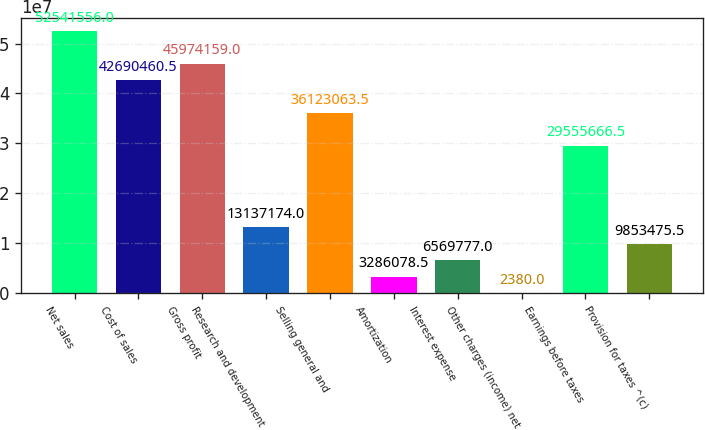<chart> <loc_0><loc_0><loc_500><loc_500><bar_chart><fcel>Net sales<fcel>Cost of sales<fcel>Gross profit<fcel>Research and development<fcel>Selling general and<fcel>Amortization<fcel>Interest expense<fcel>Other charges (income) net<fcel>Earnings before taxes<fcel>Provision for taxes ^(c)<nl><fcel>5.25416e+07<fcel>4.26905e+07<fcel>4.59742e+07<fcel>1.31372e+07<fcel>3.61231e+07<fcel>3.28608e+06<fcel>6.56978e+06<fcel>2380<fcel>2.95557e+07<fcel>9.85348e+06<nl></chart> 